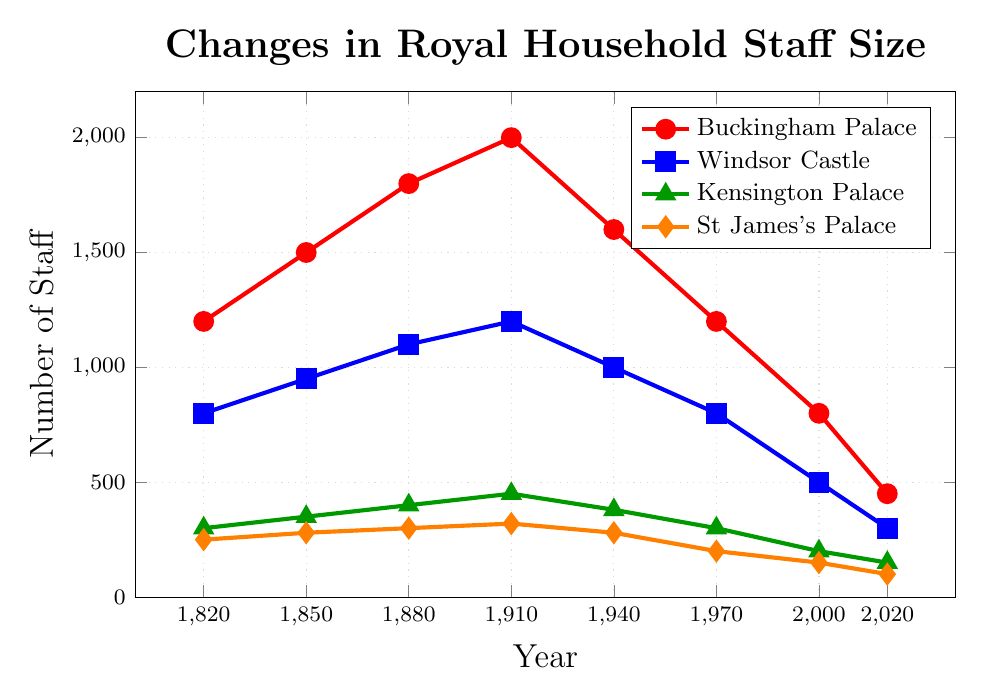how much did the staff size in Buckingham Palace decrease from its peak in 1910 to 2020? The peak staff size for Buckingham Palace was 2000 in 1910. By 2020, it had decreased to 450. The decrease is calculated as 2000 - 450 = 1550
Answer: 1550 Which palace experienced the largest staff size in 1910? In 1910, the staff sizes were: Buckingham Palace (2000), Windsor Castle (1200), Kensington Palace (450), St James's Palace (320). Buckingham Palace had the largest staff size.
Answer: Buckingham Palace What is the overall trend in the staff size at St James's Palace over the 200-year period? Initially, in 1820, the staff size at St James's Palace was 250. It rose to 320 by 1910, but then consistently declined to reach 100 by 2020. The overall trend is a significant decrease.
Answer: Decreasing How did the staff size change at Windsor Castle between 1880 and 2000? In 1880, Windsor Castle had 1100 staff members, and by 2000, this number had dropped to 500. The change in staff size is 1100 - 500 = 600
Answer: Decreased by 600 Between which two consecutive periods did Kensington Palace see the largest decline in staff size? Comparing the differences between consecutive periods: (450-380=70 between 1910-1940), (380-300=80 between 1940-1970), (300-200=100 between 1970-2000), (200-150=50 between 2000-2020). The largest decline is from 1970 to 2000 with 100
Answer: 1970 to 2000 What was the average staff size at Kensington Palace in the 20th century (1901-2000)? Kensington Palace staff sizes in the 20th century are: 1910 (450), 1940 (380), 1970 (300), 2000 (200). The sum is 450+380+300+200 = 1330. There are 4 data points, so the average is 1330 / 4 = 332.5
Answer: 332.5 Which palace had the smallest staff size in 1850 and what was it? In 1850, the staff sizes were: Buckingham Palace (1500), Windsor Castle (950), Kensington Palace (350), St James's Palace (280). St James's Palace had the smallest staff with 280
Answer: St James's Palace, 280 What is the difference between the staff sizes at Buckingham Palace and Windsor Castle in 2020? In 2020, Buckingham Palace had 450 staff members and Windsor Castle had 300. The difference is 450 - 300 = 150
Answer: 150 Which palace had the least variation in staff size from 1820 to 2020? We need to look at the range of staff sizes for each palace: 
- Buckingham Palace: 2000 - 450 = 1550
- Windsor Castle: 1200 - 300 = 900
- Kensington Palace: 450 - 150 = 300
- St James's Palace: 320 - 100 = 220
St James's Palace had the least variation at 220
Answer: St James's Palace 